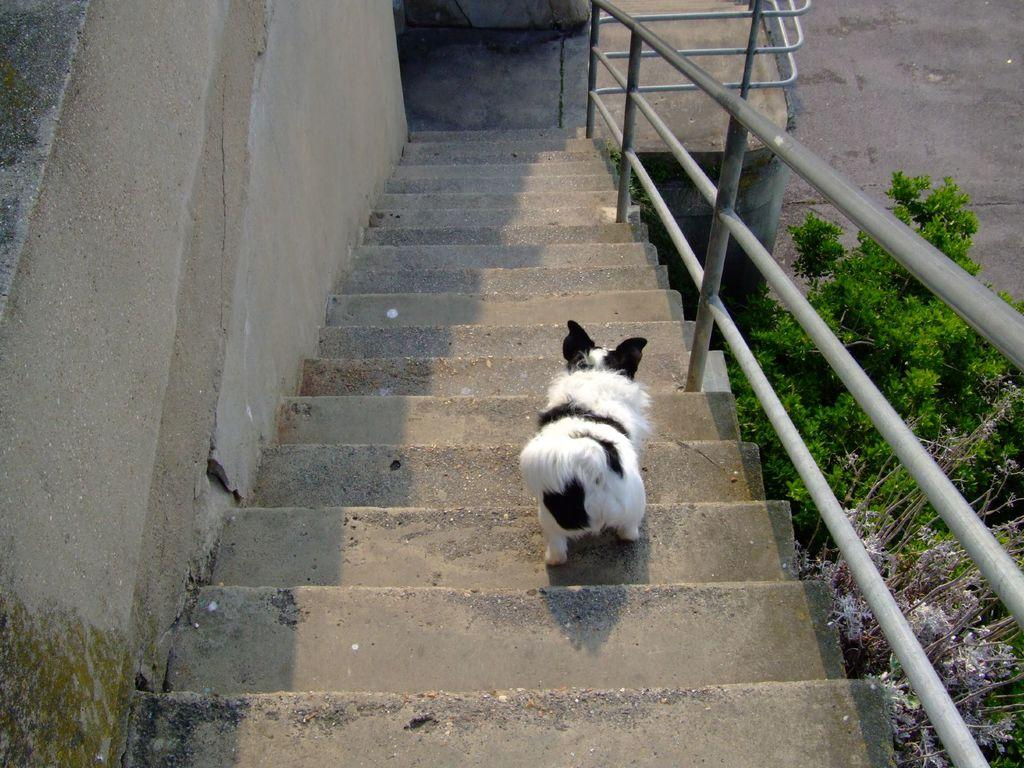What type of animal is present in the image? There is a dog in the image. Can you describe the color of the dog? The dog is white and black in color. Where is the dog located in the image? The dog is on the stairs. What else can be seen in the image besides the dog? There are stairs and trees visible in the image. What is the amount of paint used on the canvas in the image? There is no canvas or paint present in the image; it features a dog on the stairs. 